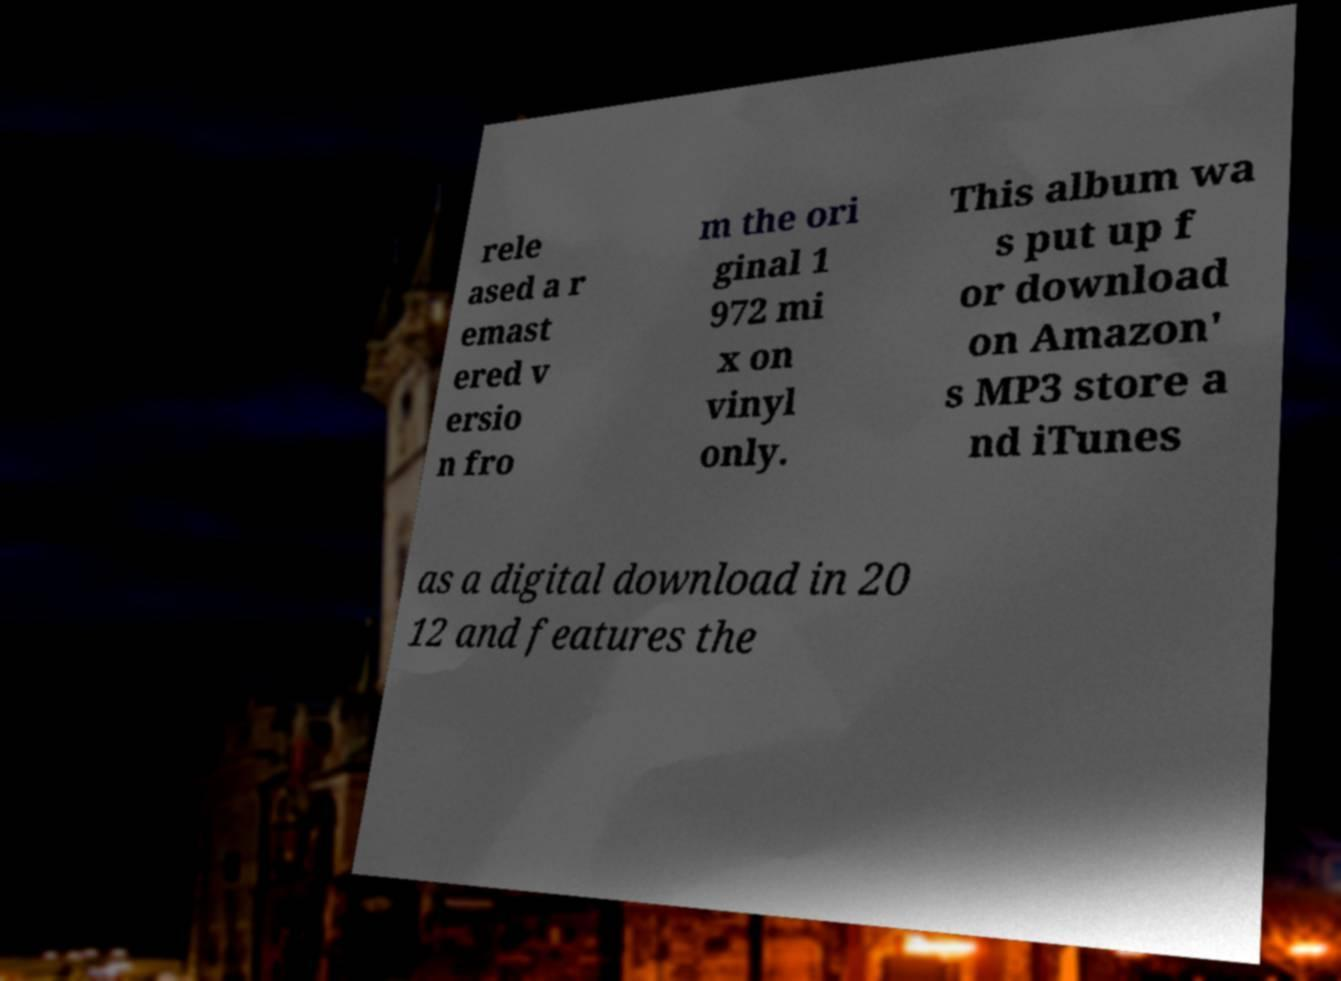Please read and relay the text visible in this image. What does it say? rele ased a r emast ered v ersio n fro m the ori ginal 1 972 mi x on vinyl only. This album wa s put up f or download on Amazon' s MP3 store a nd iTunes as a digital download in 20 12 and features the 